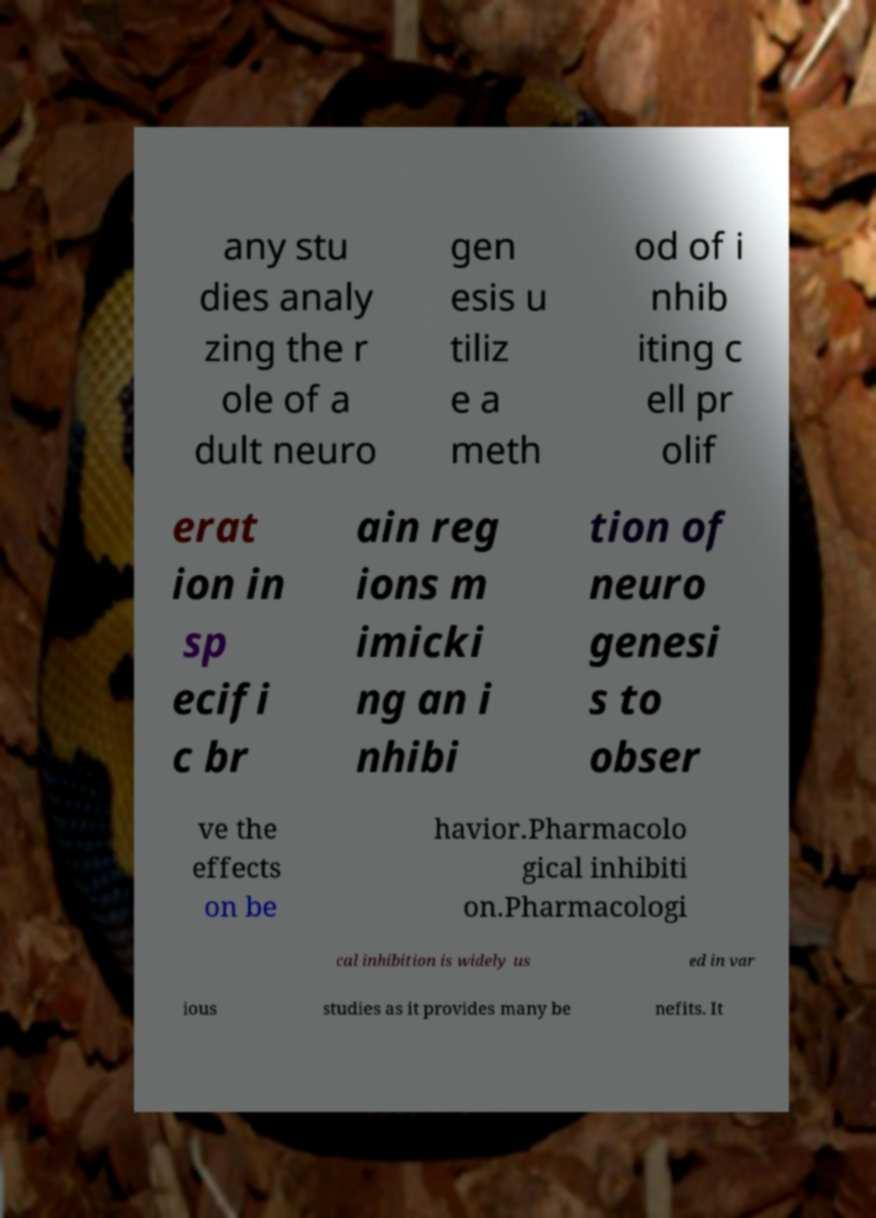Could you extract and type out the text from this image? any stu dies analy zing the r ole of a dult neuro gen esis u tiliz e a meth od of i nhib iting c ell pr olif erat ion in sp ecifi c br ain reg ions m imicki ng an i nhibi tion of neuro genesi s to obser ve the effects on be havior.Pharmacolo gical inhibiti on.Pharmacologi cal inhibition is widely us ed in var ious studies as it provides many be nefits. It 